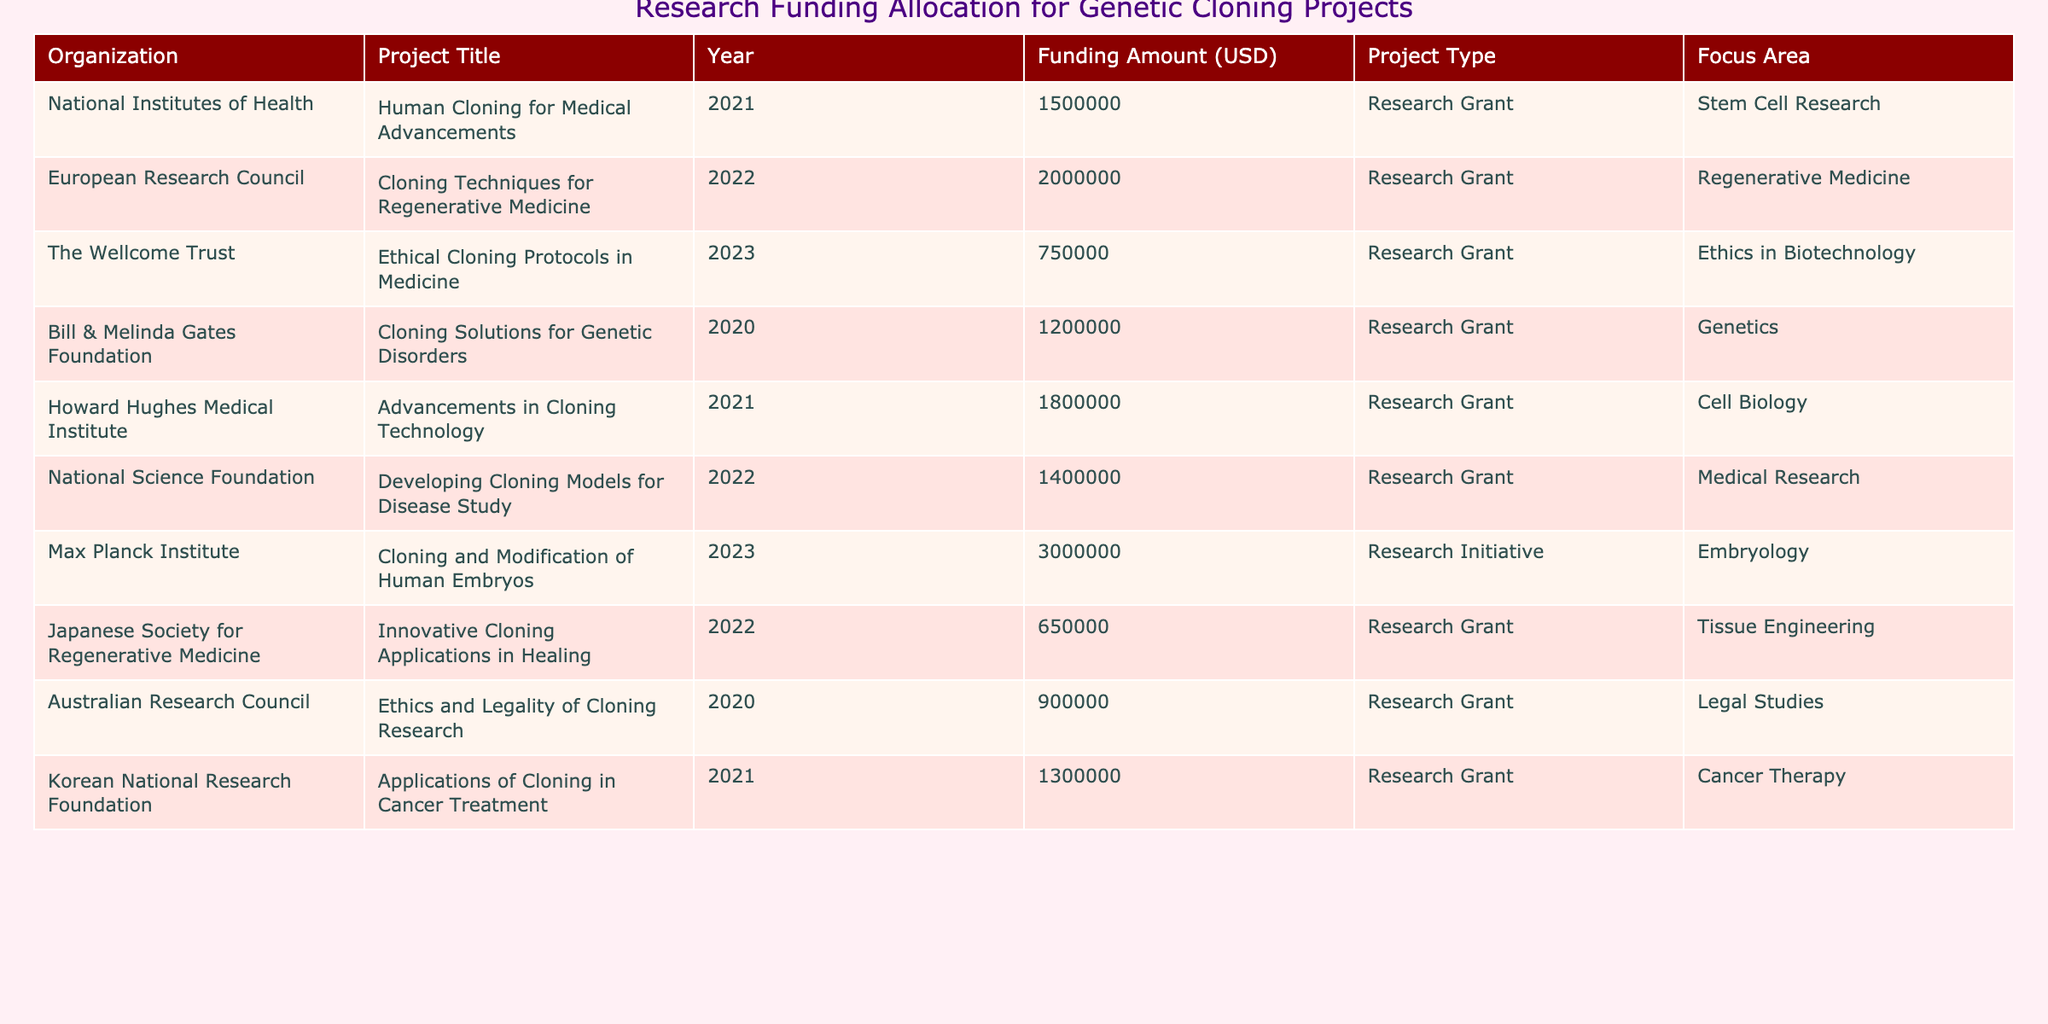What is the total funding amount allocated for the project titled "Cloning Solutions for Genetic Disorders"? The table lists the project title "Cloning Solutions for Genetic Disorders" under the Bill & Melinda Gates Foundation with a funding amount of 1,200,000 USD.
Answer: 1,200,000 USD Which organization funded the project "Cloning and Modification of Human Embryos"? The project "Cloning and Modification of Human Embryos" is funded by the Max Planck Institute, as stated in the table.
Answer: Max Planck Institute What is the average funding amount for projects focused on "Ethics in Biotechnology"? There is one project in that category titled "Ethical Cloning Protocols in Medicine" funded for 750,000 USD. Since there's only one data point, the average is 750,000 USD.
Answer: 750,000 USD How many projects received funding from the National Institutes of Health? The National Institutes of Health funded only one project, "Human Cloning for Medical Advancements", according to the table.
Answer: 1 Which project received the highest funding amount and how much was it? The project "Cloning and Modification of Human Embryos" received the highest funding amount of 3,000,000 USD from the Max Planck Institute.
Answer: Cloning and Modification of Human Embryos, 3,000,000 USD What is the total funding allocated to projects in the area of "Cancer Therapy"? The table indicates that only the project "Applications of Cloning in Cancer Treatment" was funded, with an amount of 1,300,000 USD. Thus, the total is 1,300,000 USD.
Answer: 1,300,000 USD Are there any projects that received funding for "Tissue Engineering"? Yes, the table shows that the project "Innovative Cloning Applications in Healing," which focuses on Tissue Engineering, received 650,000 USD.
Answer: Yes What is the difference in funding amounts between the highest and lowest funded projects listed? The highest funded project is "Cloning and Modification of Human Embryos" at 3,000,000 USD, and the lowest is "Innovative Cloning Applications in Healing" at 650,000 USD. Therefore, the difference is 3,000,000 - 650,000 = 2,350,000 USD.
Answer: 2,350,000 USD Which project, focusing on "Regenerative Medicine," received a higher funding amount than 1 million USD? The project "Cloning Techniques for Regenerative Medicine" received 2,000,000 USD, which is higher than 1 million USD.
Answer: Cloning Techniques for Regenerative Medicine What percentage of the total funding amount from all projects is allocated to the "Cell Biology" focus area? First, calculate the total funding amount: 1,500,000 + 2,000,000 + 750,000 + 1,200,000 + 1,800,000 + 1,400,000 + 3,000,000 + 650,000 + 900,000 + 1,300,000 = 15,450,000 USD. The funding for "Cell Biology" is 1,800,000 USD. The percentage is (1,800,000 / 15,450,000) * 100 = 11.65%.
Answer: 11.65% 